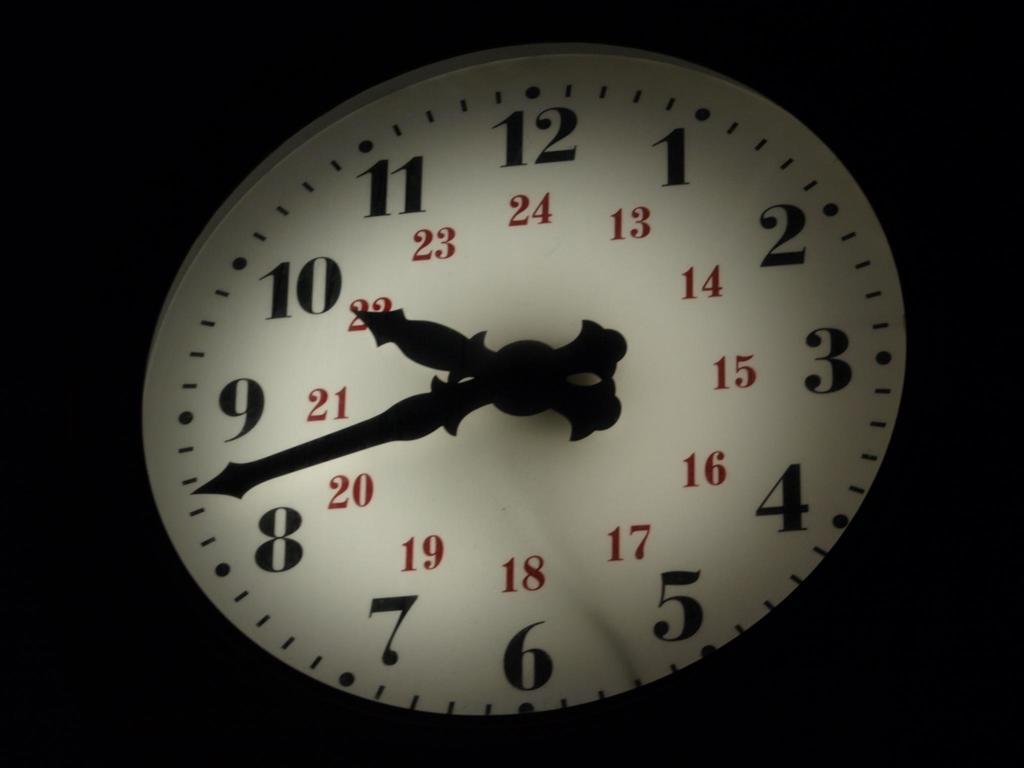Please provide a concise description of this image. In this image we can see a clock. 